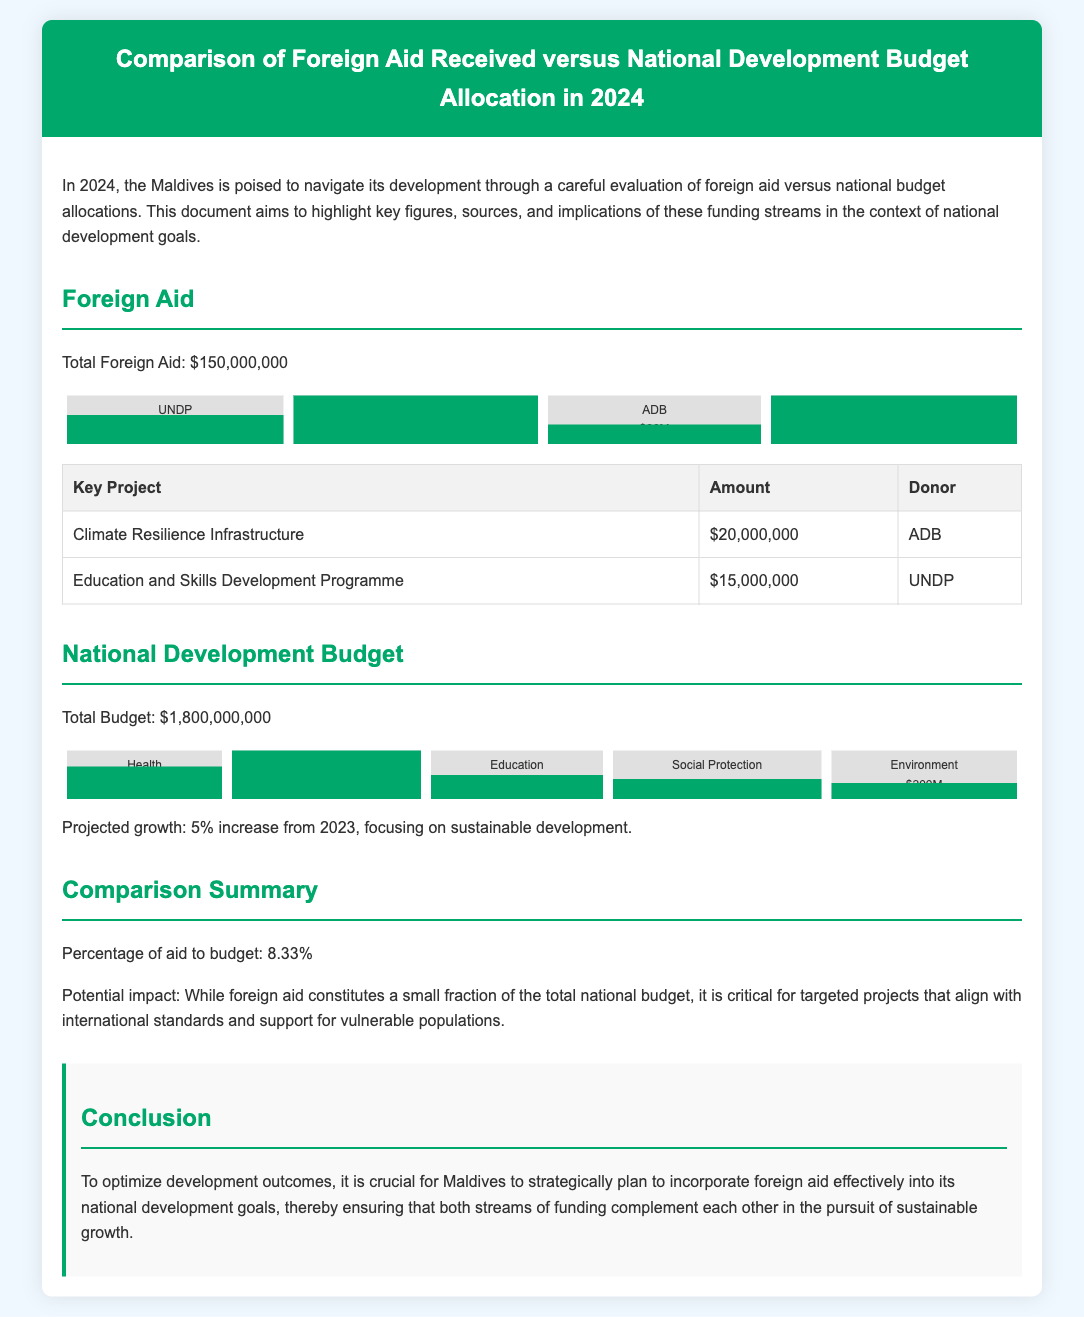What is the total foreign aid for 2024? The document states that the total foreign aid is $150,000,000.
Answer: $150,000,000 What is the budget allocation for infrastructure? The document specifies that the budget allocation for infrastructure is $600,000,000.
Answer: $600,000,000 Which organization provides the highest foreign aid? According to the document, the World Bank provides the highest foreign aid at $50,000,000.
Answer: World Bank What percentage of foreign aid contributes to the national budget? The document indicates that the percentage of aid to budget is 8.33%.
Answer: 8.33% What is the projected growth rate for the national development budget in 2024? The projected growth rate in the document is a 5% increase from 2023.
Answer: 5% Which sector has the lowest budget allocation? The document mentions that the environment sector has the lowest budget allocation of $200,000,000.
Answer: Environment How much funding is allocated for Health? The document shows that the health budget allocation is $400,000,000.
Answer: $400,000,000 What is a key project funded by ADB? The document lists "Climate Resilience Infrastructure" as a key project funded by ADB for $20,000,000.
Answer: Climate Resilience Infrastructure What implication does foreign aid have according to the document? The document states that foreign aid is critical for targeted projects that support vulnerable populations.
Answer: Critical for targeted projects 